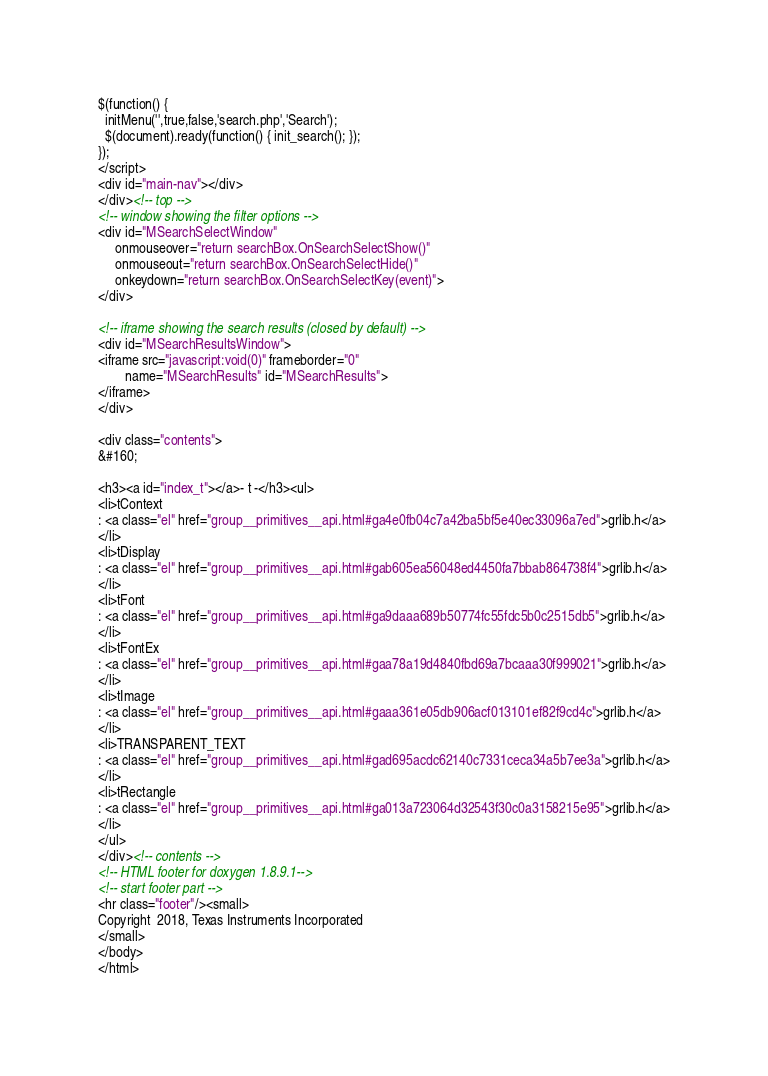Convert code to text. <code><loc_0><loc_0><loc_500><loc_500><_HTML_>$(function() {
  initMenu('',true,false,'search.php','Search');
  $(document).ready(function() { init_search(); });
});
</script>
<div id="main-nav"></div>
</div><!-- top -->
<!-- window showing the filter options -->
<div id="MSearchSelectWindow"
     onmouseover="return searchBox.OnSearchSelectShow()"
     onmouseout="return searchBox.OnSearchSelectHide()"
     onkeydown="return searchBox.OnSearchSelectKey(event)">
</div>

<!-- iframe showing the search results (closed by default) -->
<div id="MSearchResultsWindow">
<iframe src="javascript:void(0)" frameborder="0" 
        name="MSearchResults" id="MSearchResults">
</iframe>
</div>

<div class="contents">
&#160;

<h3><a id="index_t"></a>- t -</h3><ul>
<li>tContext
: <a class="el" href="group__primitives__api.html#ga4e0fb04c7a42ba5bf5e40ec33096a7ed">grlib.h</a>
</li>
<li>tDisplay
: <a class="el" href="group__primitives__api.html#gab605ea56048ed4450fa7bbab864738f4">grlib.h</a>
</li>
<li>tFont
: <a class="el" href="group__primitives__api.html#ga9daaa689b50774fc55fdc5b0c2515db5">grlib.h</a>
</li>
<li>tFontEx
: <a class="el" href="group__primitives__api.html#gaa78a19d4840fbd69a7bcaaa30f999021">grlib.h</a>
</li>
<li>tImage
: <a class="el" href="group__primitives__api.html#gaaa361e05db906acf013101ef82f9cd4c">grlib.h</a>
</li>
<li>TRANSPARENT_TEXT
: <a class="el" href="group__primitives__api.html#gad695acdc62140c7331ceca34a5b7ee3a">grlib.h</a>
</li>
<li>tRectangle
: <a class="el" href="group__primitives__api.html#ga013a723064d32543f30c0a3158215e95">grlib.h</a>
</li>
</ul>
</div><!-- contents -->
<!-- HTML footer for doxygen 1.8.9.1-->
<!-- start footer part -->
<hr class="footer"/><small>
Copyright  2018, Texas Instruments Incorporated
</small>
</body>
</html>
</code> 